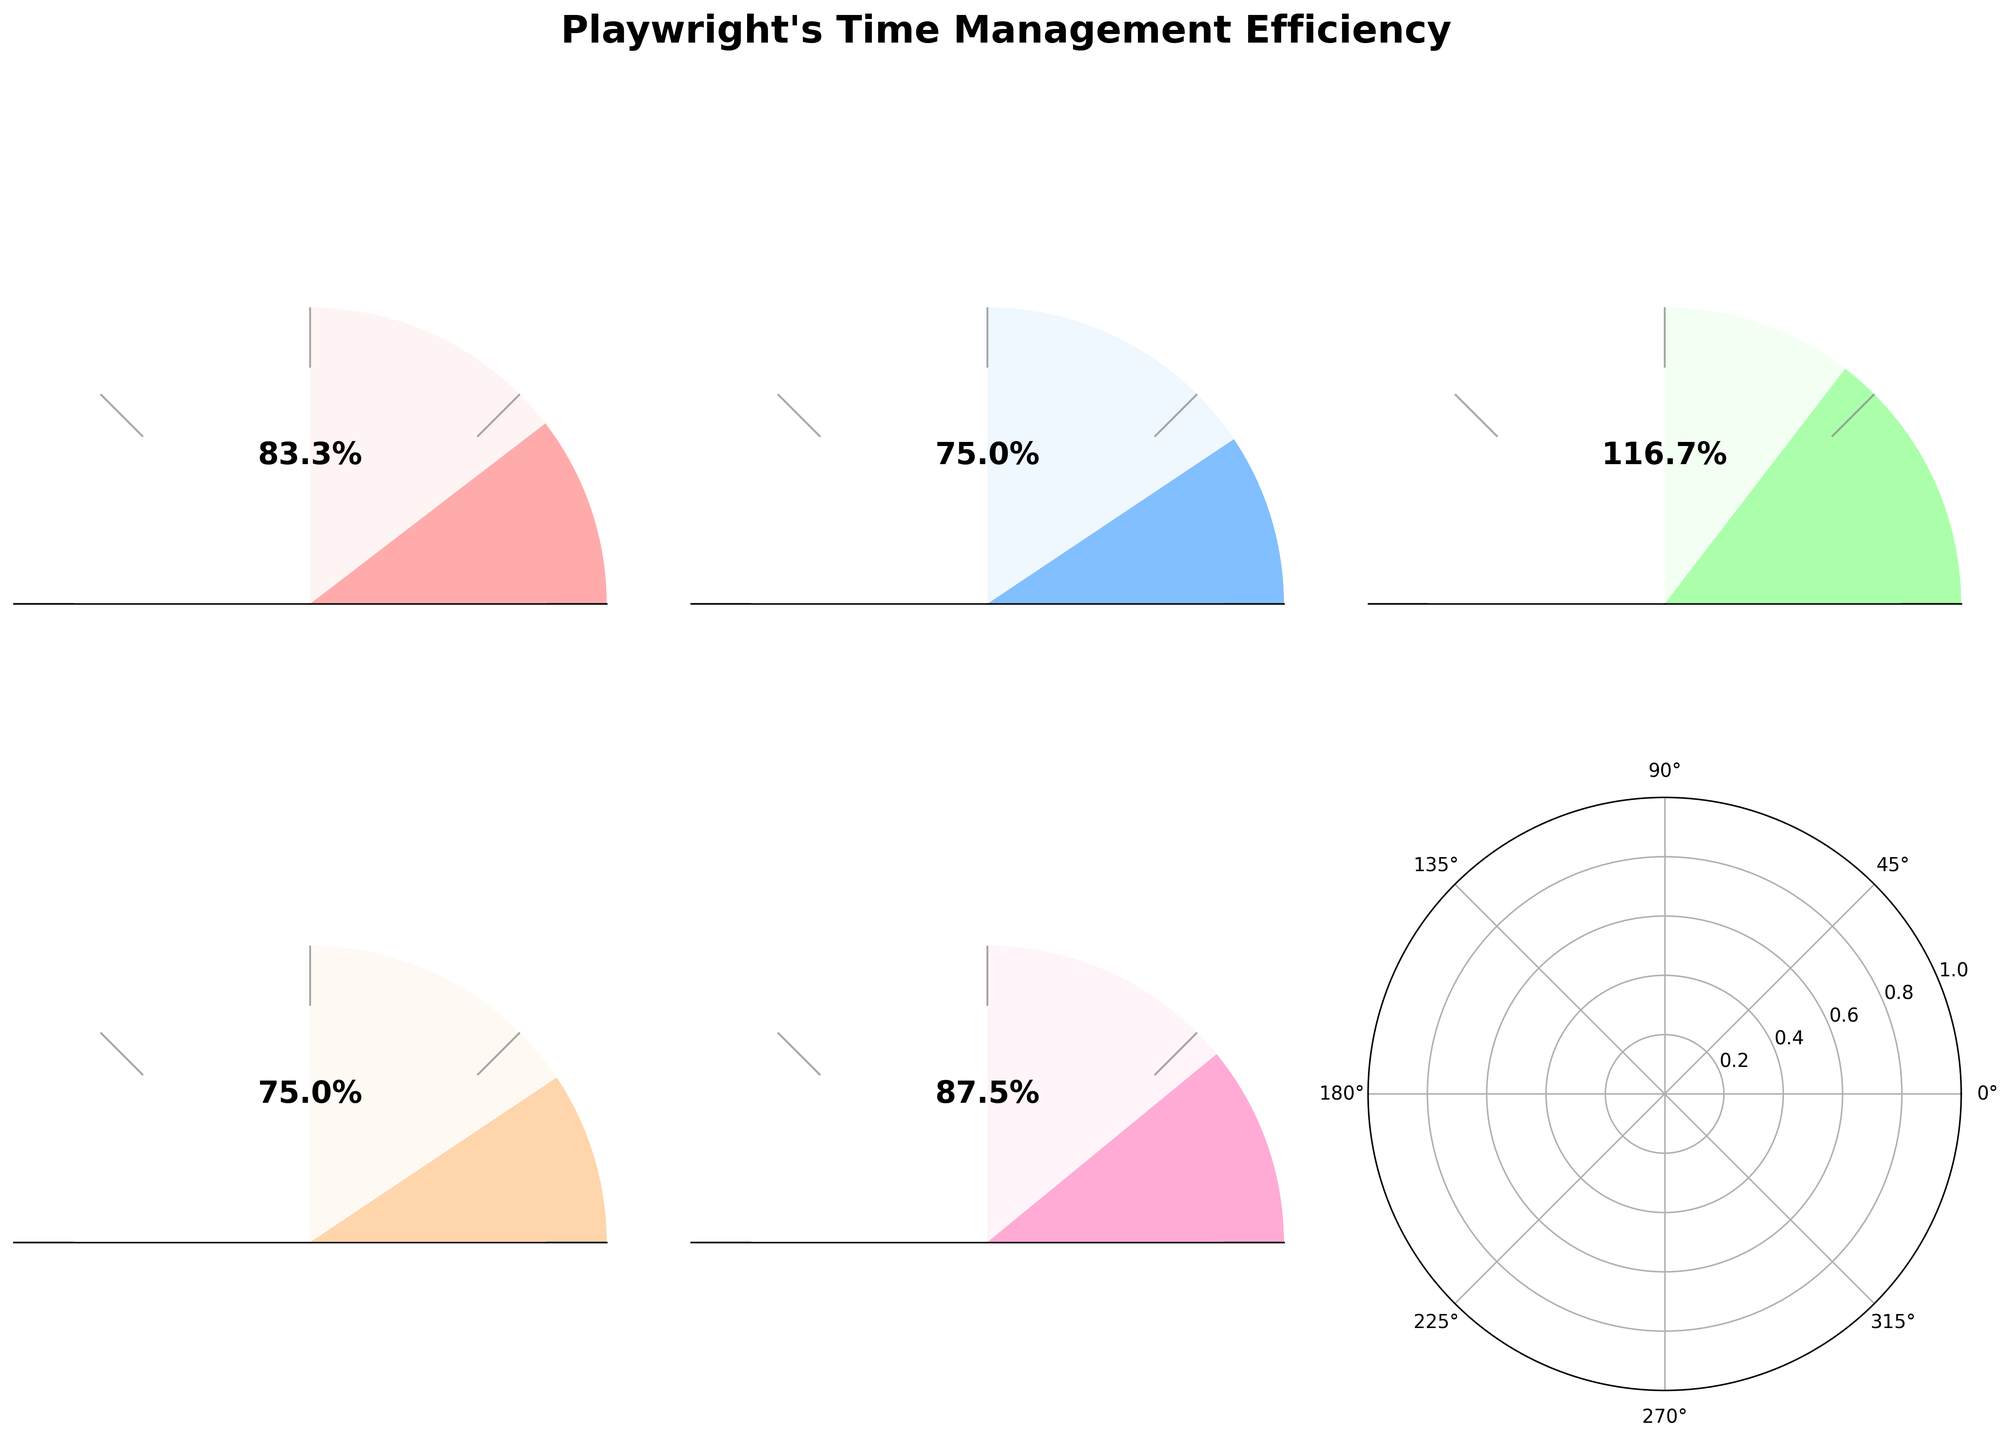What's the efficiency of the Morning Writing Session? The efficiency of the Morning Writing Session is directly shown on the gauge as 83.33%.
Answer: 83.33% Which session has the lowest efficiency? From the gauges, the session with the lowest efficiency is the Afternoon Revision, which has an efficiency of 75%.
Answer: Afternoon Revision How much planned time is given for the Weekend Script Development? The planned time for the Weekend Script Development can be seen from the provided data as 240 minutes.
Answer: 240 minutes What is the difference in actual time between Morning Writing Session and Evening Brainstorming? The actual time for Morning Writing Session is 150 minutes, and for Evening Brainstorming, it is 105 minutes. The difference is 150 - 105 = 45 minutes.
Answer: 45 minutes What's the average efficiency of all sessions combined? To find the average efficiency: (83.33 + 75 + 116.67 + 75 + 87.5) / 5. This calculates to: 437.5 / 5 = 87.5%.
Answer: 87.5% Which session exceeded its planned time and by how much? The Evening Brainstorming session exceeded its planned time. The planned time was 90 minutes, and the actual time was 105 minutes. The exceedance is 105 - 90 = 15 minutes.
Answer: Evening Brainstorming, 15 minutes Which session has the highest efficiency? From the gauges, the session with the highest efficiency is the Evening Brainstorming with an efficiency of 116.67%.
Answer: Evening Brainstorming What's the total planned time for all sessions? Sum up all the planned times: 180 + 120 + 90 + 60 + 240 = 690 minutes.
Answer: 690 minutes Compare the efficiency of the Morning Writing Session and Afternoon Revision. Which one is higher, and by how much? The Morning Writing Session has an efficiency of 83.33%, and the Afternoon Revision has 75%. 83.33% is higher by 83.33 - 75 = 8.33%.
Answer: Morning Writing Session, by 8.33% 